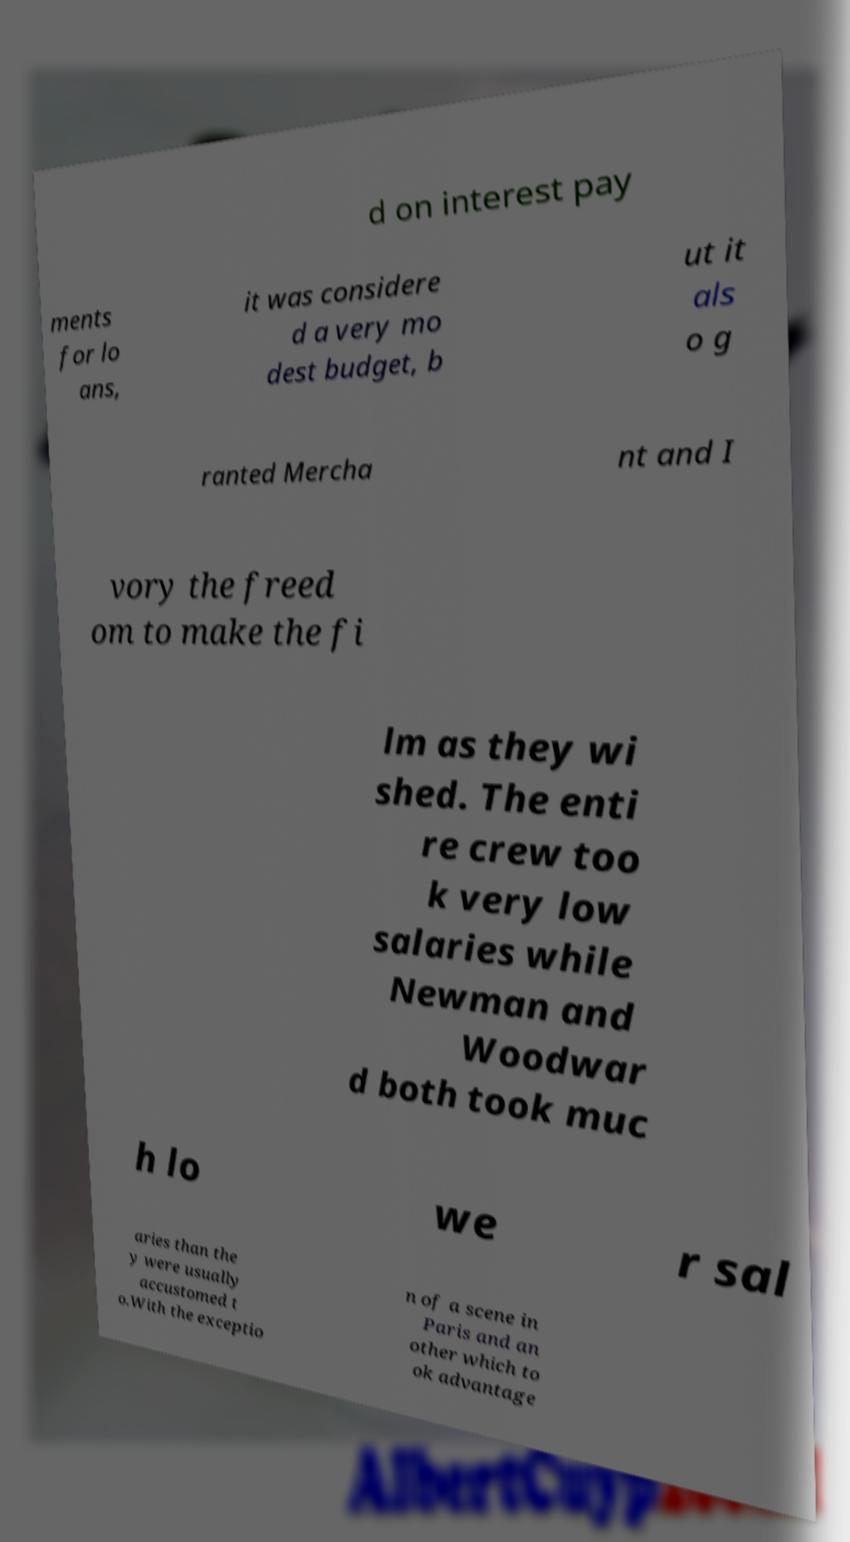Can you accurately transcribe the text from the provided image for me? d on interest pay ments for lo ans, it was considere d a very mo dest budget, b ut it als o g ranted Mercha nt and I vory the freed om to make the fi lm as they wi shed. The enti re crew too k very low salaries while Newman and Woodwar d both took muc h lo we r sal aries than the y were usually accustomed t o.With the exceptio n of a scene in Paris and an other which to ok advantage 